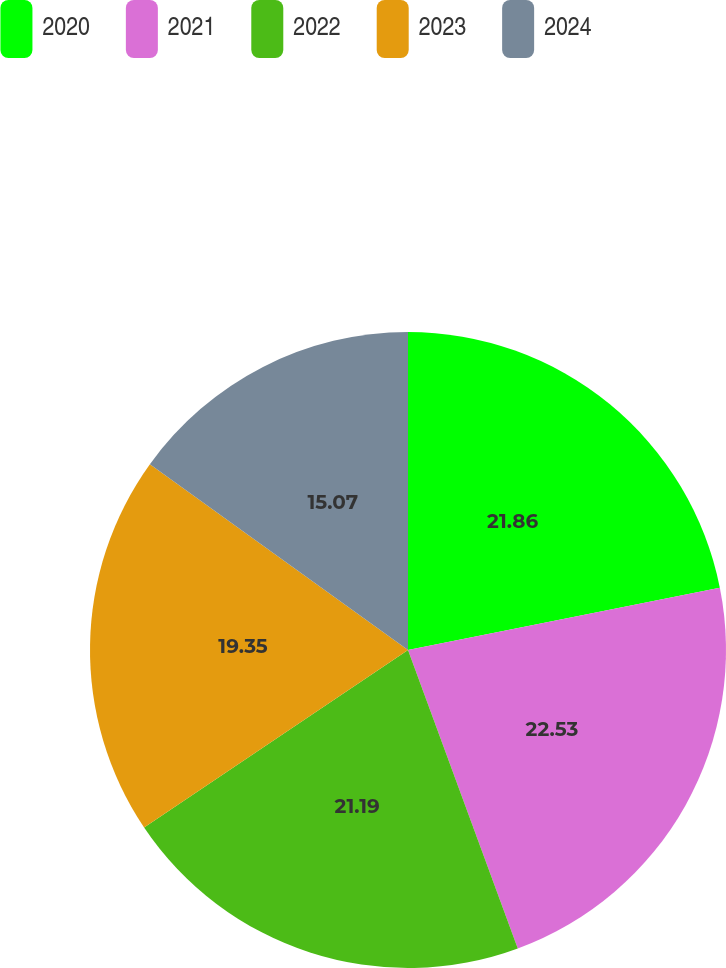Convert chart. <chart><loc_0><loc_0><loc_500><loc_500><pie_chart><fcel>2020<fcel>2021<fcel>2022<fcel>2023<fcel>2024<nl><fcel>21.86%<fcel>22.53%<fcel>21.19%<fcel>19.35%<fcel>15.07%<nl></chart> 